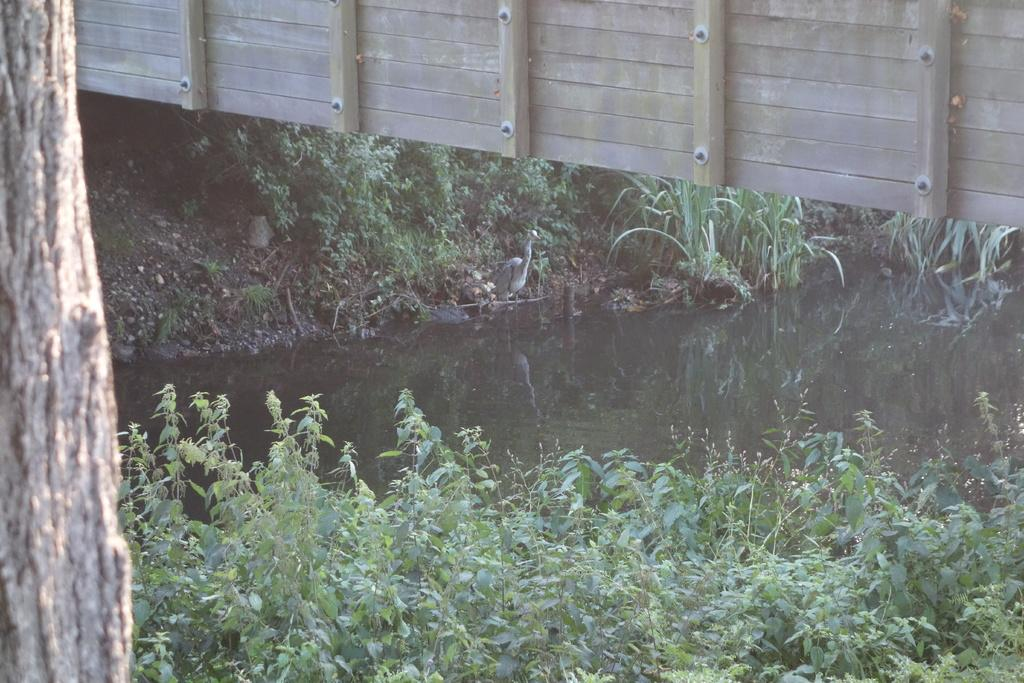What is the primary element visible in the image? There is water in the image. What type of vegetation is present on either side of the water? There are plants on either side of the water. What structure is located above the water in the image? There is a fence wall above the water. How many angles can be seen in the image? There is no specific mention of angles in the image, so it is not possible to determine the number of angles present. 